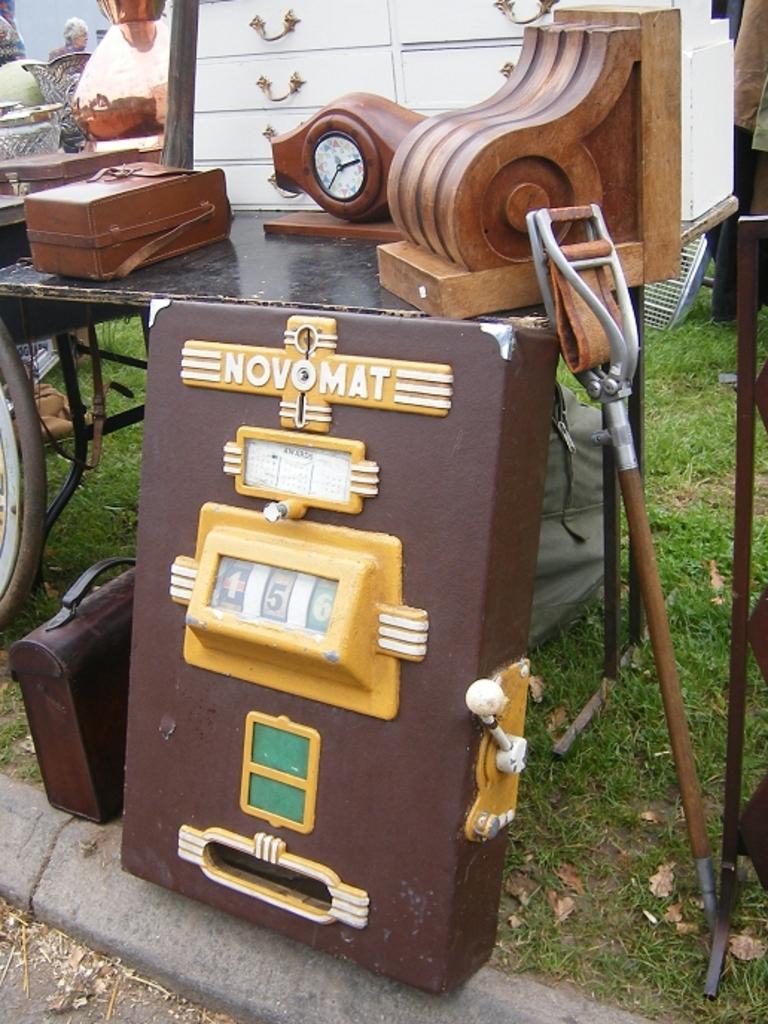Please provide a concise description of this image. In this image there are tables and we can see a shovel. At the bottom there is grass and we can see a briefcase and a board. On the left there is a person. 